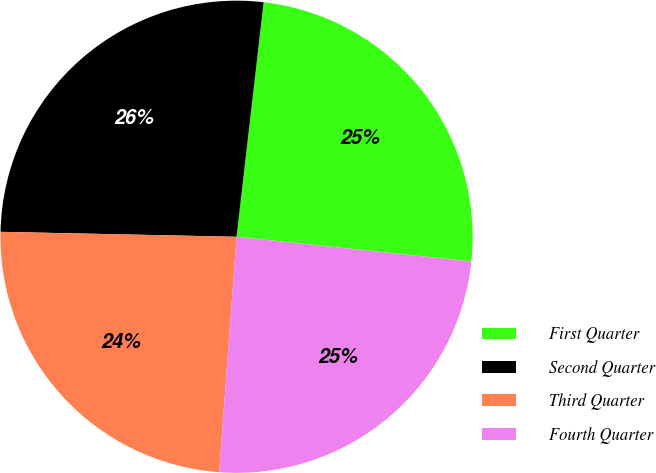<chart> <loc_0><loc_0><loc_500><loc_500><pie_chart><fcel>First Quarter<fcel>Second Quarter<fcel>Third Quarter<fcel>Fourth Quarter<nl><fcel>24.84%<fcel>26.5%<fcel>24.16%<fcel>24.51%<nl></chart> 